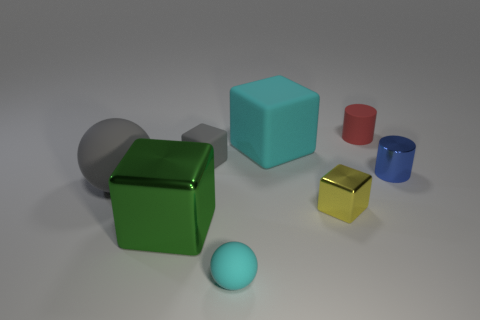How many tiny blue things are the same shape as the red rubber thing?
Give a very brief answer. 1. Is the number of rubber spheres that are right of the cyan rubber block the same as the number of small gray metallic cylinders?
Provide a short and direct response. Yes. The green object that is the same size as the gray matte ball is what shape?
Provide a short and direct response. Cube. Is there a blue object of the same shape as the small red object?
Make the answer very short. Yes. There is a cyan rubber object behind the metal block to the left of the tiny gray thing; is there a green shiny block on the left side of it?
Keep it short and to the point. Yes. Are there more gray rubber cubes in front of the big green shiny cube than cyan balls to the right of the tiny blue cylinder?
Ensure brevity in your answer.  No. What material is the other cube that is the same size as the yellow metallic block?
Ensure brevity in your answer.  Rubber. How many big things are gray objects or matte balls?
Your answer should be very brief. 1. Is the shape of the yellow thing the same as the red thing?
Give a very brief answer. No. What number of rubber things are behind the gray ball and on the left side of the yellow object?
Provide a short and direct response. 2. 